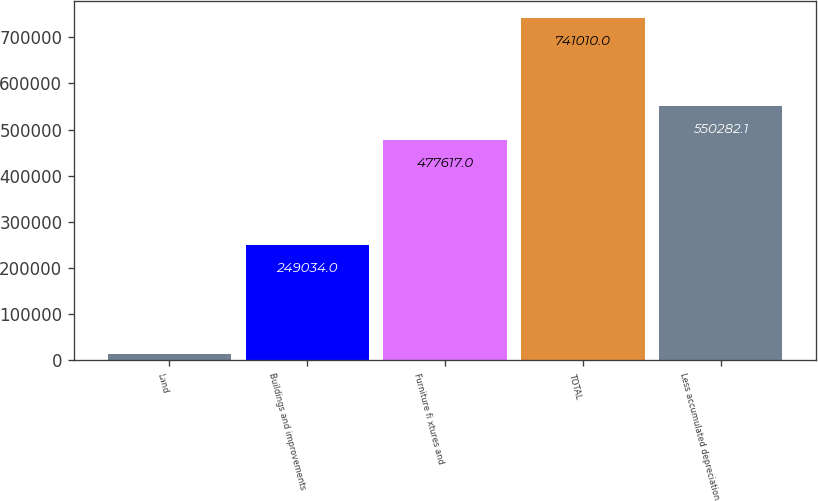Convert chart. <chart><loc_0><loc_0><loc_500><loc_500><bar_chart><fcel>Land<fcel>Buildings and improvements<fcel>Furniture fi xtures and<fcel>TOTAL<fcel>Less accumulated depreciation<nl><fcel>14359<fcel>249034<fcel>477617<fcel>741010<fcel>550282<nl></chart> 